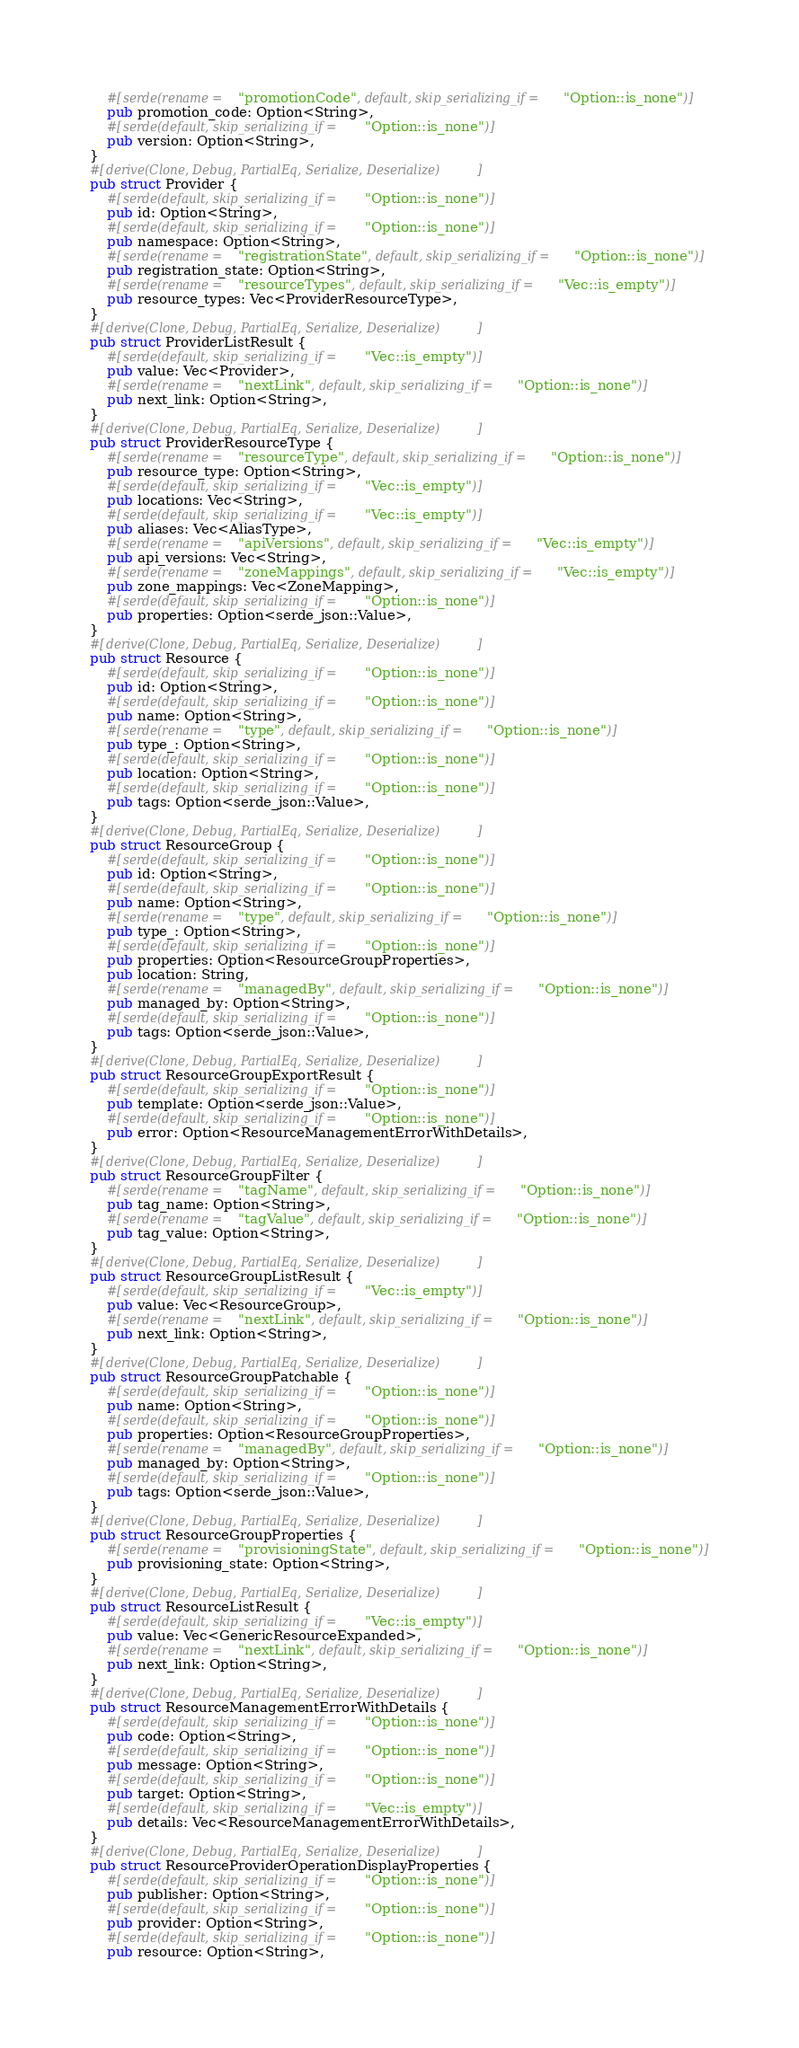Convert code to text. <code><loc_0><loc_0><loc_500><loc_500><_Rust_>    #[serde(rename = "promotionCode", default, skip_serializing_if = "Option::is_none")]
    pub promotion_code: Option<String>,
    #[serde(default, skip_serializing_if = "Option::is_none")]
    pub version: Option<String>,
}
#[derive(Clone, Debug, PartialEq, Serialize, Deserialize)]
pub struct Provider {
    #[serde(default, skip_serializing_if = "Option::is_none")]
    pub id: Option<String>,
    #[serde(default, skip_serializing_if = "Option::is_none")]
    pub namespace: Option<String>,
    #[serde(rename = "registrationState", default, skip_serializing_if = "Option::is_none")]
    pub registration_state: Option<String>,
    #[serde(rename = "resourceTypes", default, skip_serializing_if = "Vec::is_empty")]
    pub resource_types: Vec<ProviderResourceType>,
}
#[derive(Clone, Debug, PartialEq, Serialize, Deserialize)]
pub struct ProviderListResult {
    #[serde(default, skip_serializing_if = "Vec::is_empty")]
    pub value: Vec<Provider>,
    #[serde(rename = "nextLink", default, skip_serializing_if = "Option::is_none")]
    pub next_link: Option<String>,
}
#[derive(Clone, Debug, PartialEq, Serialize, Deserialize)]
pub struct ProviderResourceType {
    #[serde(rename = "resourceType", default, skip_serializing_if = "Option::is_none")]
    pub resource_type: Option<String>,
    #[serde(default, skip_serializing_if = "Vec::is_empty")]
    pub locations: Vec<String>,
    #[serde(default, skip_serializing_if = "Vec::is_empty")]
    pub aliases: Vec<AliasType>,
    #[serde(rename = "apiVersions", default, skip_serializing_if = "Vec::is_empty")]
    pub api_versions: Vec<String>,
    #[serde(rename = "zoneMappings", default, skip_serializing_if = "Vec::is_empty")]
    pub zone_mappings: Vec<ZoneMapping>,
    #[serde(default, skip_serializing_if = "Option::is_none")]
    pub properties: Option<serde_json::Value>,
}
#[derive(Clone, Debug, PartialEq, Serialize, Deserialize)]
pub struct Resource {
    #[serde(default, skip_serializing_if = "Option::is_none")]
    pub id: Option<String>,
    #[serde(default, skip_serializing_if = "Option::is_none")]
    pub name: Option<String>,
    #[serde(rename = "type", default, skip_serializing_if = "Option::is_none")]
    pub type_: Option<String>,
    #[serde(default, skip_serializing_if = "Option::is_none")]
    pub location: Option<String>,
    #[serde(default, skip_serializing_if = "Option::is_none")]
    pub tags: Option<serde_json::Value>,
}
#[derive(Clone, Debug, PartialEq, Serialize, Deserialize)]
pub struct ResourceGroup {
    #[serde(default, skip_serializing_if = "Option::is_none")]
    pub id: Option<String>,
    #[serde(default, skip_serializing_if = "Option::is_none")]
    pub name: Option<String>,
    #[serde(rename = "type", default, skip_serializing_if = "Option::is_none")]
    pub type_: Option<String>,
    #[serde(default, skip_serializing_if = "Option::is_none")]
    pub properties: Option<ResourceGroupProperties>,
    pub location: String,
    #[serde(rename = "managedBy", default, skip_serializing_if = "Option::is_none")]
    pub managed_by: Option<String>,
    #[serde(default, skip_serializing_if = "Option::is_none")]
    pub tags: Option<serde_json::Value>,
}
#[derive(Clone, Debug, PartialEq, Serialize, Deserialize)]
pub struct ResourceGroupExportResult {
    #[serde(default, skip_serializing_if = "Option::is_none")]
    pub template: Option<serde_json::Value>,
    #[serde(default, skip_serializing_if = "Option::is_none")]
    pub error: Option<ResourceManagementErrorWithDetails>,
}
#[derive(Clone, Debug, PartialEq, Serialize, Deserialize)]
pub struct ResourceGroupFilter {
    #[serde(rename = "tagName", default, skip_serializing_if = "Option::is_none")]
    pub tag_name: Option<String>,
    #[serde(rename = "tagValue", default, skip_serializing_if = "Option::is_none")]
    pub tag_value: Option<String>,
}
#[derive(Clone, Debug, PartialEq, Serialize, Deserialize)]
pub struct ResourceGroupListResult {
    #[serde(default, skip_serializing_if = "Vec::is_empty")]
    pub value: Vec<ResourceGroup>,
    #[serde(rename = "nextLink", default, skip_serializing_if = "Option::is_none")]
    pub next_link: Option<String>,
}
#[derive(Clone, Debug, PartialEq, Serialize, Deserialize)]
pub struct ResourceGroupPatchable {
    #[serde(default, skip_serializing_if = "Option::is_none")]
    pub name: Option<String>,
    #[serde(default, skip_serializing_if = "Option::is_none")]
    pub properties: Option<ResourceGroupProperties>,
    #[serde(rename = "managedBy", default, skip_serializing_if = "Option::is_none")]
    pub managed_by: Option<String>,
    #[serde(default, skip_serializing_if = "Option::is_none")]
    pub tags: Option<serde_json::Value>,
}
#[derive(Clone, Debug, PartialEq, Serialize, Deserialize)]
pub struct ResourceGroupProperties {
    #[serde(rename = "provisioningState", default, skip_serializing_if = "Option::is_none")]
    pub provisioning_state: Option<String>,
}
#[derive(Clone, Debug, PartialEq, Serialize, Deserialize)]
pub struct ResourceListResult {
    #[serde(default, skip_serializing_if = "Vec::is_empty")]
    pub value: Vec<GenericResourceExpanded>,
    #[serde(rename = "nextLink", default, skip_serializing_if = "Option::is_none")]
    pub next_link: Option<String>,
}
#[derive(Clone, Debug, PartialEq, Serialize, Deserialize)]
pub struct ResourceManagementErrorWithDetails {
    #[serde(default, skip_serializing_if = "Option::is_none")]
    pub code: Option<String>,
    #[serde(default, skip_serializing_if = "Option::is_none")]
    pub message: Option<String>,
    #[serde(default, skip_serializing_if = "Option::is_none")]
    pub target: Option<String>,
    #[serde(default, skip_serializing_if = "Vec::is_empty")]
    pub details: Vec<ResourceManagementErrorWithDetails>,
}
#[derive(Clone, Debug, PartialEq, Serialize, Deserialize)]
pub struct ResourceProviderOperationDisplayProperties {
    #[serde(default, skip_serializing_if = "Option::is_none")]
    pub publisher: Option<String>,
    #[serde(default, skip_serializing_if = "Option::is_none")]
    pub provider: Option<String>,
    #[serde(default, skip_serializing_if = "Option::is_none")]
    pub resource: Option<String>,</code> 